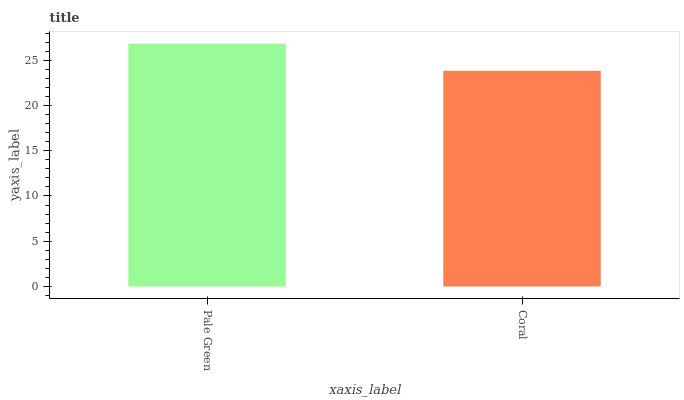Is Coral the minimum?
Answer yes or no. Yes. Is Pale Green the maximum?
Answer yes or no. Yes. Is Coral the maximum?
Answer yes or no. No. Is Pale Green greater than Coral?
Answer yes or no. Yes. Is Coral less than Pale Green?
Answer yes or no. Yes. Is Coral greater than Pale Green?
Answer yes or no. No. Is Pale Green less than Coral?
Answer yes or no. No. Is Pale Green the high median?
Answer yes or no. Yes. Is Coral the low median?
Answer yes or no. Yes. Is Coral the high median?
Answer yes or no. No. Is Pale Green the low median?
Answer yes or no. No. 